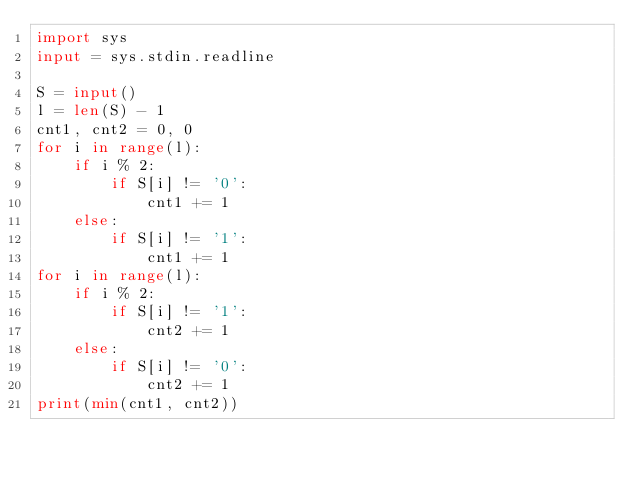<code> <loc_0><loc_0><loc_500><loc_500><_Python_>import sys
input = sys.stdin.readline

S = input()
l = len(S) - 1
cnt1, cnt2 = 0, 0
for i in range(l):
    if i % 2:
        if S[i] != '0':
            cnt1 += 1
    else:
        if S[i] != '1':
            cnt1 += 1
for i in range(l):
    if i % 2:
        if S[i] != '1':
            cnt2 += 1
    else:
        if S[i] != '0':
            cnt2 += 1
print(min(cnt1, cnt2))</code> 